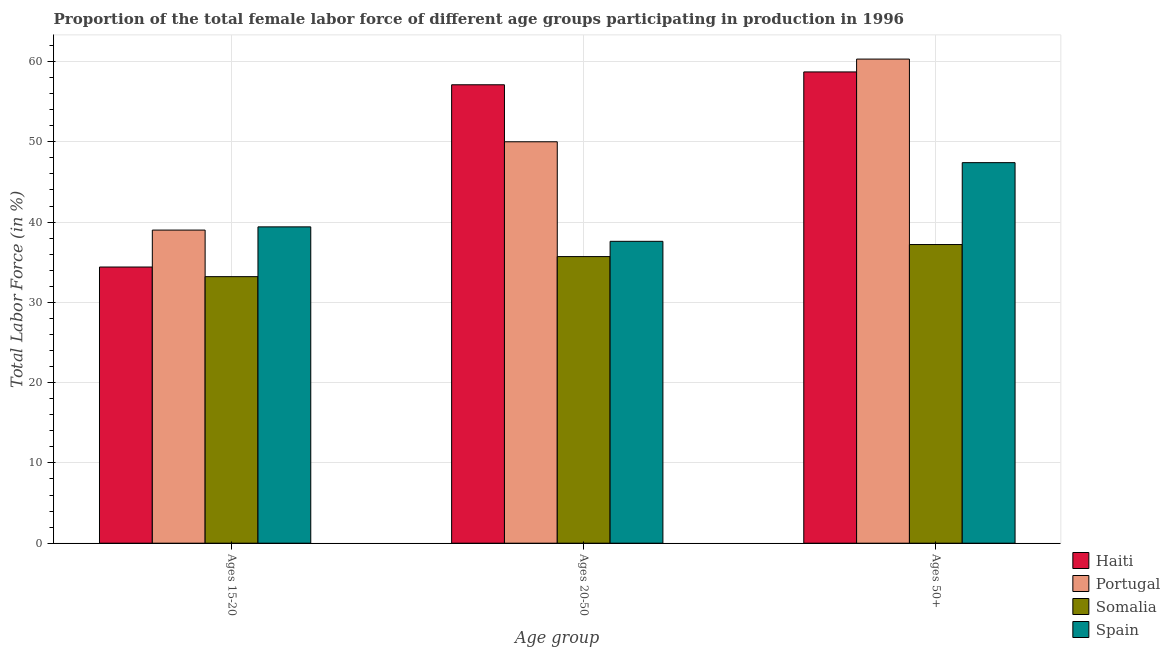How many different coloured bars are there?
Your response must be concise. 4. Are the number of bars per tick equal to the number of legend labels?
Give a very brief answer. Yes. How many bars are there on the 2nd tick from the right?
Provide a short and direct response. 4. What is the label of the 2nd group of bars from the left?
Provide a short and direct response. Ages 20-50. What is the percentage of female labor force above age 50 in Haiti?
Your answer should be very brief. 58.7. Across all countries, what is the maximum percentage of female labor force within the age group 20-50?
Offer a very short reply. 57.1. Across all countries, what is the minimum percentage of female labor force above age 50?
Offer a terse response. 37.2. In which country was the percentage of female labor force within the age group 15-20 maximum?
Provide a short and direct response. Spain. In which country was the percentage of female labor force above age 50 minimum?
Keep it short and to the point. Somalia. What is the total percentage of female labor force above age 50 in the graph?
Your answer should be very brief. 203.6. What is the difference between the percentage of female labor force within the age group 20-50 in Somalia and that in Haiti?
Your answer should be very brief. -21.4. What is the difference between the percentage of female labor force within the age group 20-50 in Portugal and the percentage of female labor force above age 50 in Spain?
Give a very brief answer. 2.6. What is the average percentage of female labor force within the age group 15-20 per country?
Your answer should be compact. 36.5. What is the difference between the percentage of female labor force within the age group 20-50 and percentage of female labor force within the age group 15-20 in Spain?
Make the answer very short. -1.8. In how many countries, is the percentage of female labor force within the age group 20-50 greater than 34 %?
Your answer should be very brief. 4. What is the ratio of the percentage of female labor force within the age group 20-50 in Portugal to that in Spain?
Make the answer very short. 1.33. What is the difference between the highest and the second highest percentage of female labor force within the age group 20-50?
Give a very brief answer. 7.1. What is the difference between the highest and the lowest percentage of female labor force within the age group 15-20?
Offer a terse response. 6.2. How many bars are there?
Offer a very short reply. 12. How many countries are there in the graph?
Make the answer very short. 4. Are the values on the major ticks of Y-axis written in scientific E-notation?
Make the answer very short. No. Does the graph contain any zero values?
Provide a succinct answer. No. Does the graph contain grids?
Provide a succinct answer. Yes. How many legend labels are there?
Provide a succinct answer. 4. What is the title of the graph?
Provide a succinct answer. Proportion of the total female labor force of different age groups participating in production in 1996. Does "Macao" appear as one of the legend labels in the graph?
Keep it short and to the point. No. What is the label or title of the X-axis?
Your response must be concise. Age group. What is the label or title of the Y-axis?
Provide a succinct answer. Total Labor Force (in %). What is the Total Labor Force (in %) in Haiti in Ages 15-20?
Your answer should be very brief. 34.4. What is the Total Labor Force (in %) of Portugal in Ages 15-20?
Keep it short and to the point. 39. What is the Total Labor Force (in %) of Somalia in Ages 15-20?
Keep it short and to the point. 33.2. What is the Total Labor Force (in %) in Spain in Ages 15-20?
Ensure brevity in your answer.  39.4. What is the Total Labor Force (in %) in Haiti in Ages 20-50?
Offer a terse response. 57.1. What is the Total Labor Force (in %) in Somalia in Ages 20-50?
Offer a terse response. 35.7. What is the Total Labor Force (in %) in Spain in Ages 20-50?
Offer a very short reply. 37.6. What is the Total Labor Force (in %) of Haiti in Ages 50+?
Offer a very short reply. 58.7. What is the Total Labor Force (in %) of Portugal in Ages 50+?
Keep it short and to the point. 60.3. What is the Total Labor Force (in %) of Somalia in Ages 50+?
Offer a very short reply. 37.2. What is the Total Labor Force (in %) in Spain in Ages 50+?
Provide a short and direct response. 47.4. Across all Age group, what is the maximum Total Labor Force (in %) of Haiti?
Your answer should be very brief. 58.7. Across all Age group, what is the maximum Total Labor Force (in %) in Portugal?
Your response must be concise. 60.3. Across all Age group, what is the maximum Total Labor Force (in %) in Somalia?
Provide a succinct answer. 37.2. Across all Age group, what is the maximum Total Labor Force (in %) in Spain?
Keep it short and to the point. 47.4. Across all Age group, what is the minimum Total Labor Force (in %) of Haiti?
Your answer should be very brief. 34.4. Across all Age group, what is the minimum Total Labor Force (in %) in Portugal?
Make the answer very short. 39. Across all Age group, what is the minimum Total Labor Force (in %) of Somalia?
Give a very brief answer. 33.2. Across all Age group, what is the minimum Total Labor Force (in %) in Spain?
Offer a terse response. 37.6. What is the total Total Labor Force (in %) of Haiti in the graph?
Offer a terse response. 150.2. What is the total Total Labor Force (in %) in Portugal in the graph?
Your answer should be very brief. 149.3. What is the total Total Labor Force (in %) of Somalia in the graph?
Your answer should be compact. 106.1. What is the total Total Labor Force (in %) of Spain in the graph?
Ensure brevity in your answer.  124.4. What is the difference between the Total Labor Force (in %) in Haiti in Ages 15-20 and that in Ages 20-50?
Your answer should be very brief. -22.7. What is the difference between the Total Labor Force (in %) in Haiti in Ages 15-20 and that in Ages 50+?
Your response must be concise. -24.3. What is the difference between the Total Labor Force (in %) of Portugal in Ages 15-20 and that in Ages 50+?
Give a very brief answer. -21.3. What is the difference between the Total Labor Force (in %) in Somalia in Ages 15-20 and that in Ages 50+?
Your answer should be compact. -4. What is the difference between the Total Labor Force (in %) in Haiti in Ages 20-50 and that in Ages 50+?
Your answer should be very brief. -1.6. What is the difference between the Total Labor Force (in %) in Portugal in Ages 20-50 and that in Ages 50+?
Keep it short and to the point. -10.3. What is the difference between the Total Labor Force (in %) of Haiti in Ages 15-20 and the Total Labor Force (in %) of Portugal in Ages 20-50?
Provide a short and direct response. -15.6. What is the difference between the Total Labor Force (in %) of Haiti in Ages 15-20 and the Total Labor Force (in %) of Somalia in Ages 20-50?
Offer a terse response. -1.3. What is the difference between the Total Labor Force (in %) in Portugal in Ages 15-20 and the Total Labor Force (in %) in Somalia in Ages 20-50?
Ensure brevity in your answer.  3.3. What is the difference between the Total Labor Force (in %) of Portugal in Ages 15-20 and the Total Labor Force (in %) of Spain in Ages 20-50?
Keep it short and to the point. 1.4. What is the difference between the Total Labor Force (in %) in Somalia in Ages 15-20 and the Total Labor Force (in %) in Spain in Ages 20-50?
Your answer should be compact. -4.4. What is the difference between the Total Labor Force (in %) in Haiti in Ages 15-20 and the Total Labor Force (in %) in Portugal in Ages 50+?
Offer a very short reply. -25.9. What is the difference between the Total Labor Force (in %) in Haiti in Ages 15-20 and the Total Labor Force (in %) in Somalia in Ages 50+?
Your answer should be compact. -2.8. What is the difference between the Total Labor Force (in %) in Haiti in Ages 15-20 and the Total Labor Force (in %) in Spain in Ages 50+?
Ensure brevity in your answer.  -13. What is the difference between the Total Labor Force (in %) of Portugal in Ages 15-20 and the Total Labor Force (in %) of Spain in Ages 50+?
Offer a very short reply. -8.4. What is the difference between the Total Labor Force (in %) in Haiti in Ages 20-50 and the Total Labor Force (in %) in Somalia in Ages 50+?
Ensure brevity in your answer.  19.9. What is the difference between the Total Labor Force (in %) of Haiti in Ages 20-50 and the Total Labor Force (in %) of Spain in Ages 50+?
Your answer should be very brief. 9.7. What is the average Total Labor Force (in %) in Haiti per Age group?
Your answer should be very brief. 50.07. What is the average Total Labor Force (in %) in Portugal per Age group?
Keep it short and to the point. 49.77. What is the average Total Labor Force (in %) in Somalia per Age group?
Give a very brief answer. 35.37. What is the average Total Labor Force (in %) of Spain per Age group?
Give a very brief answer. 41.47. What is the difference between the Total Labor Force (in %) of Haiti and Total Labor Force (in %) of Portugal in Ages 15-20?
Make the answer very short. -4.6. What is the difference between the Total Labor Force (in %) in Portugal and Total Labor Force (in %) in Somalia in Ages 15-20?
Provide a short and direct response. 5.8. What is the difference between the Total Labor Force (in %) of Portugal and Total Labor Force (in %) of Spain in Ages 15-20?
Give a very brief answer. -0.4. What is the difference between the Total Labor Force (in %) of Haiti and Total Labor Force (in %) of Portugal in Ages 20-50?
Provide a succinct answer. 7.1. What is the difference between the Total Labor Force (in %) in Haiti and Total Labor Force (in %) in Somalia in Ages 20-50?
Give a very brief answer. 21.4. What is the difference between the Total Labor Force (in %) in Portugal and Total Labor Force (in %) in Somalia in Ages 20-50?
Give a very brief answer. 14.3. What is the difference between the Total Labor Force (in %) in Portugal and Total Labor Force (in %) in Spain in Ages 20-50?
Keep it short and to the point. 12.4. What is the difference between the Total Labor Force (in %) in Haiti and Total Labor Force (in %) in Spain in Ages 50+?
Ensure brevity in your answer.  11.3. What is the difference between the Total Labor Force (in %) of Portugal and Total Labor Force (in %) of Somalia in Ages 50+?
Provide a succinct answer. 23.1. What is the difference between the Total Labor Force (in %) in Portugal and Total Labor Force (in %) in Spain in Ages 50+?
Provide a succinct answer. 12.9. What is the ratio of the Total Labor Force (in %) in Haiti in Ages 15-20 to that in Ages 20-50?
Ensure brevity in your answer.  0.6. What is the ratio of the Total Labor Force (in %) of Portugal in Ages 15-20 to that in Ages 20-50?
Provide a short and direct response. 0.78. What is the ratio of the Total Labor Force (in %) in Somalia in Ages 15-20 to that in Ages 20-50?
Offer a very short reply. 0.93. What is the ratio of the Total Labor Force (in %) in Spain in Ages 15-20 to that in Ages 20-50?
Provide a succinct answer. 1.05. What is the ratio of the Total Labor Force (in %) of Haiti in Ages 15-20 to that in Ages 50+?
Offer a very short reply. 0.59. What is the ratio of the Total Labor Force (in %) of Portugal in Ages 15-20 to that in Ages 50+?
Keep it short and to the point. 0.65. What is the ratio of the Total Labor Force (in %) in Somalia in Ages 15-20 to that in Ages 50+?
Provide a short and direct response. 0.89. What is the ratio of the Total Labor Force (in %) of Spain in Ages 15-20 to that in Ages 50+?
Provide a short and direct response. 0.83. What is the ratio of the Total Labor Force (in %) in Haiti in Ages 20-50 to that in Ages 50+?
Provide a succinct answer. 0.97. What is the ratio of the Total Labor Force (in %) in Portugal in Ages 20-50 to that in Ages 50+?
Offer a terse response. 0.83. What is the ratio of the Total Labor Force (in %) in Somalia in Ages 20-50 to that in Ages 50+?
Give a very brief answer. 0.96. What is the ratio of the Total Labor Force (in %) of Spain in Ages 20-50 to that in Ages 50+?
Keep it short and to the point. 0.79. What is the difference between the highest and the second highest Total Labor Force (in %) of Haiti?
Provide a short and direct response. 1.6. What is the difference between the highest and the second highest Total Labor Force (in %) of Portugal?
Offer a very short reply. 10.3. What is the difference between the highest and the lowest Total Labor Force (in %) in Haiti?
Make the answer very short. 24.3. What is the difference between the highest and the lowest Total Labor Force (in %) in Portugal?
Provide a short and direct response. 21.3. What is the difference between the highest and the lowest Total Labor Force (in %) in Somalia?
Your answer should be very brief. 4. 